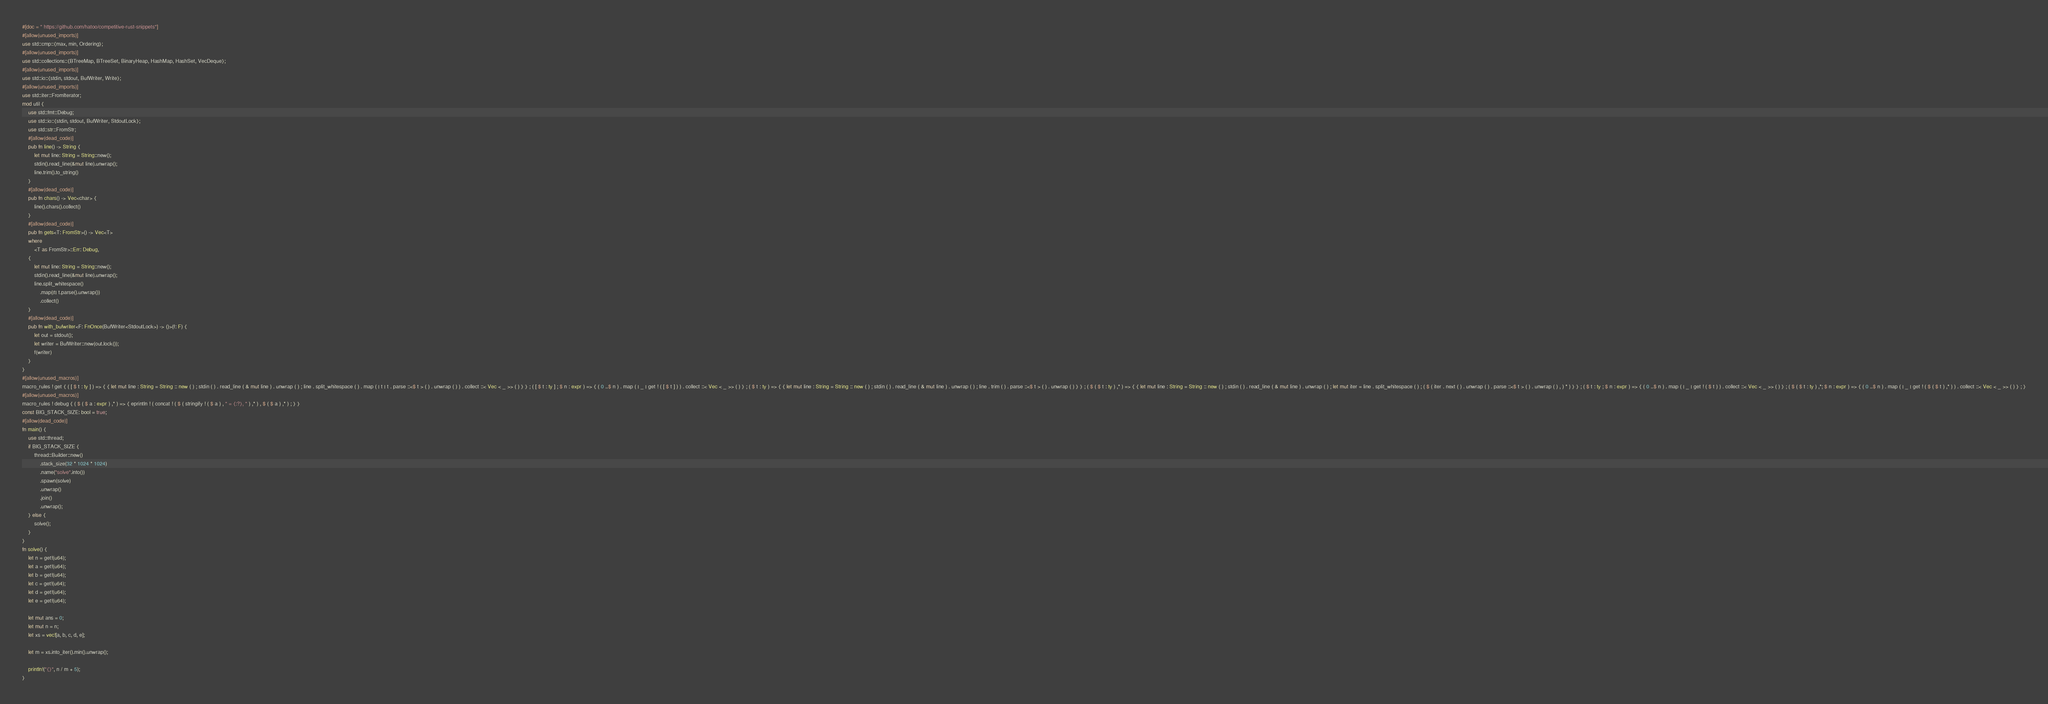Convert code to text. <code><loc_0><loc_0><loc_500><loc_500><_Rust_>#[doc = " https://github.com/hatoo/competitive-rust-snippets"]
#[allow(unused_imports)]
use std::cmp::{max, min, Ordering};
#[allow(unused_imports)]
use std::collections::{BTreeMap, BTreeSet, BinaryHeap, HashMap, HashSet, VecDeque};
#[allow(unused_imports)]
use std::io::{stdin, stdout, BufWriter, Write};
#[allow(unused_imports)]
use std::iter::FromIterator;
mod util {
    use std::fmt::Debug;
    use std::io::{stdin, stdout, BufWriter, StdoutLock};
    use std::str::FromStr;
    #[allow(dead_code)]
    pub fn line() -> String {
        let mut line: String = String::new();
        stdin().read_line(&mut line).unwrap();
        line.trim().to_string()
    }
    #[allow(dead_code)]
    pub fn chars() -> Vec<char> {
        line().chars().collect()
    }
    #[allow(dead_code)]
    pub fn gets<T: FromStr>() -> Vec<T>
    where
        <T as FromStr>::Err: Debug,
    {
        let mut line: String = String::new();
        stdin().read_line(&mut line).unwrap();
        line.split_whitespace()
            .map(|t| t.parse().unwrap())
            .collect()
    }
    #[allow(dead_code)]
    pub fn with_bufwriter<F: FnOnce(BufWriter<StdoutLock>) -> ()>(f: F) {
        let out = stdout();
        let writer = BufWriter::new(out.lock());
        f(writer)
    }
}
#[allow(unused_macros)]
macro_rules ! get { ( [ $ t : ty ] ) => { { let mut line : String = String :: new ( ) ; stdin ( ) . read_line ( & mut line ) . unwrap ( ) ; line . split_whitespace ( ) . map ( | t | t . parse ::<$ t > ( ) . unwrap ( ) ) . collect ::< Vec < _ >> ( ) } } ; ( [ $ t : ty ] ; $ n : expr ) => { ( 0 ..$ n ) . map ( | _ | get ! ( [ $ t ] ) ) . collect ::< Vec < _ >> ( ) } ; ( $ t : ty ) => { { let mut line : String = String :: new ( ) ; stdin ( ) . read_line ( & mut line ) . unwrap ( ) ; line . trim ( ) . parse ::<$ t > ( ) . unwrap ( ) } } ; ( $ ( $ t : ty ) ,* ) => { { let mut line : String = String :: new ( ) ; stdin ( ) . read_line ( & mut line ) . unwrap ( ) ; let mut iter = line . split_whitespace ( ) ; ( $ ( iter . next ( ) . unwrap ( ) . parse ::<$ t > ( ) . unwrap ( ) , ) * ) } } ; ( $ t : ty ; $ n : expr ) => { ( 0 ..$ n ) . map ( | _ | get ! ( $ t ) ) . collect ::< Vec < _ >> ( ) } ; ( $ ( $ t : ty ) ,*; $ n : expr ) => { ( 0 ..$ n ) . map ( | _ | get ! ( $ ( $ t ) ,* ) ) . collect ::< Vec < _ >> ( ) } ; }
#[allow(unused_macros)]
macro_rules ! debug { ( $ ( $ a : expr ) ,* ) => { eprintln ! ( concat ! ( $ ( stringify ! ( $ a ) , " = {:?}, " ) ,* ) , $ ( $ a ) ,* ) ; } }
const BIG_STACK_SIZE: bool = true;
#[allow(dead_code)]
fn main() {
    use std::thread;
    if BIG_STACK_SIZE {
        thread::Builder::new()
            .stack_size(32 * 1024 * 1024)
            .name("solve".into())
            .spawn(solve)
            .unwrap()
            .join()
            .unwrap();
    } else {
        solve();
    }
}
fn solve() {
    let n = get!(u64);
    let a = get!(u64);
    let b = get!(u64);
    let c = get!(u64);
    let d = get!(u64);
    let e = get!(u64);

    let mut ans = 0;
    let mut n = n;
    let xs = vec![a, b, c, d, e];

    let m = xs.into_iter().min().unwrap();

    println!("{}", n / m + 5);
}
</code> 